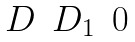<formula> <loc_0><loc_0><loc_500><loc_500>\begin{matrix} D & D _ { 1 } & 0 \end{matrix}</formula> 